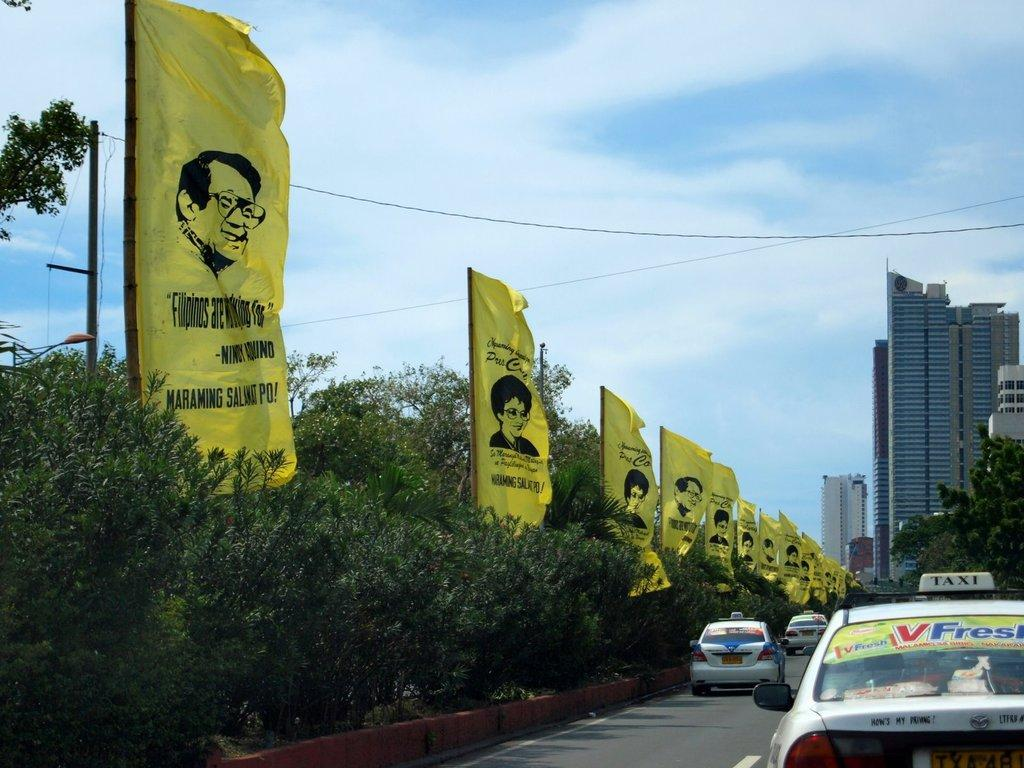<image>
Relay a brief, clear account of the picture shown. Yellow banners along a road feature Filipino people. 